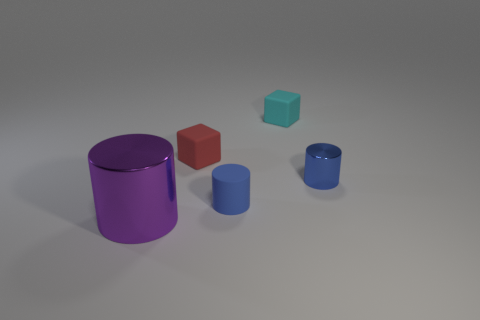How many blue cylinders must be subtracted to get 1 blue cylinders? 1 Add 1 small red matte objects. How many objects exist? 6 Subtract all blocks. How many objects are left? 3 Subtract 1 blue cylinders. How many objects are left? 4 Subtract all large blue blocks. Subtract all metal objects. How many objects are left? 3 Add 5 rubber blocks. How many rubber blocks are left? 7 Add 5 blue metal cylinders. How many blue metal cylinders exist? 6 